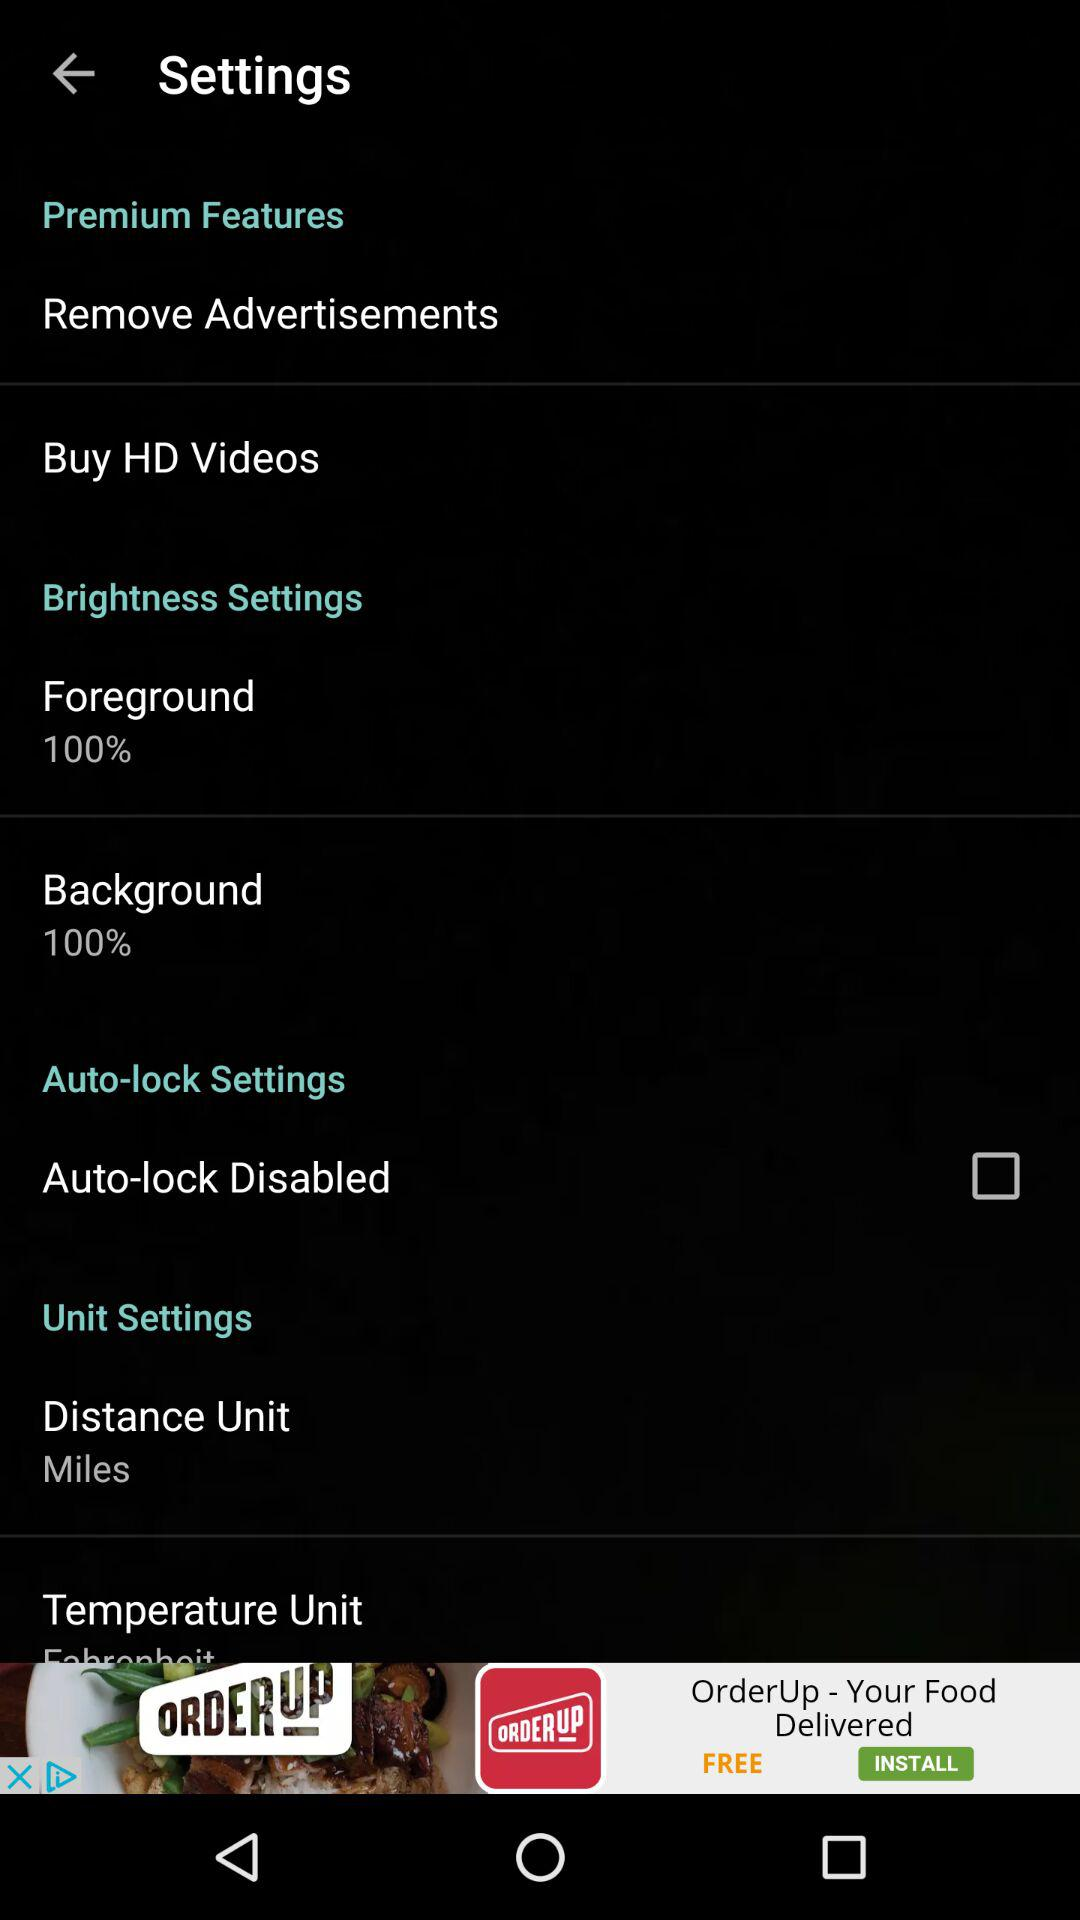What is the selected distance unit? The selected distance unit is miles. 